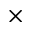<formula> <loc_0><loc_0><loc_500><loc_500>\times</formula> 